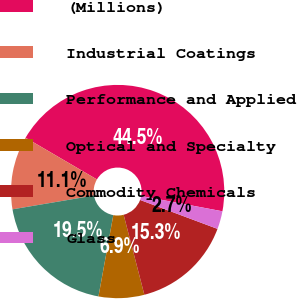Convert chart. <chart><loc_0><loc_0><loc_500><loc_500><pie_chart><fcel>(Millions)<fcel>Industrial Coatings<fcel>Performance and Applied<fcel>Optical and Specialty<fcel>Commodity Chemicals<fcel>Glass<nl><fcel>44.54%<fcel>11.09%<fcel>19.45%<fcel>6.91%<fcel>15.27%<fcel>2.73%<nl></chart> 